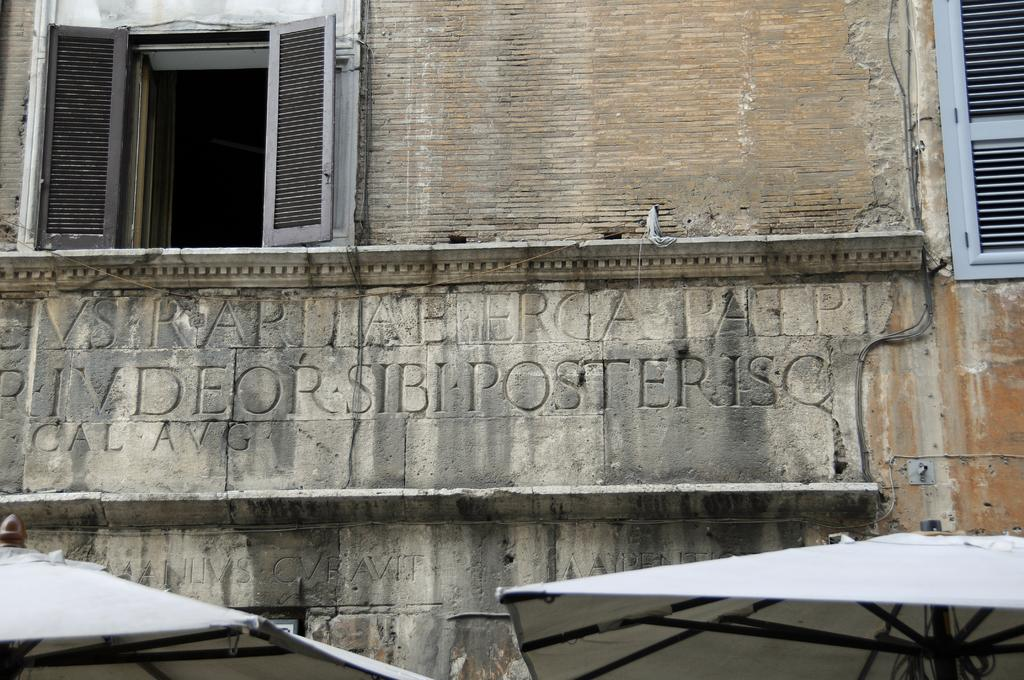What type of scene is depicted in the image? The image is an outside view of a building. How many windows can be seen in the image? There are two windows visible in the image. What additional objects are present in the image? There are two umbrellas in the image. What is the governor's opinion on the idea presented in the image? There is no governor or idea present in the image; it is a simple outside view of a building with two windows and two umbrellas. 